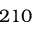Convert formula to latex. <formula><loc_0><loc_0><loc_500><loc_500>2 1 0</formula> 